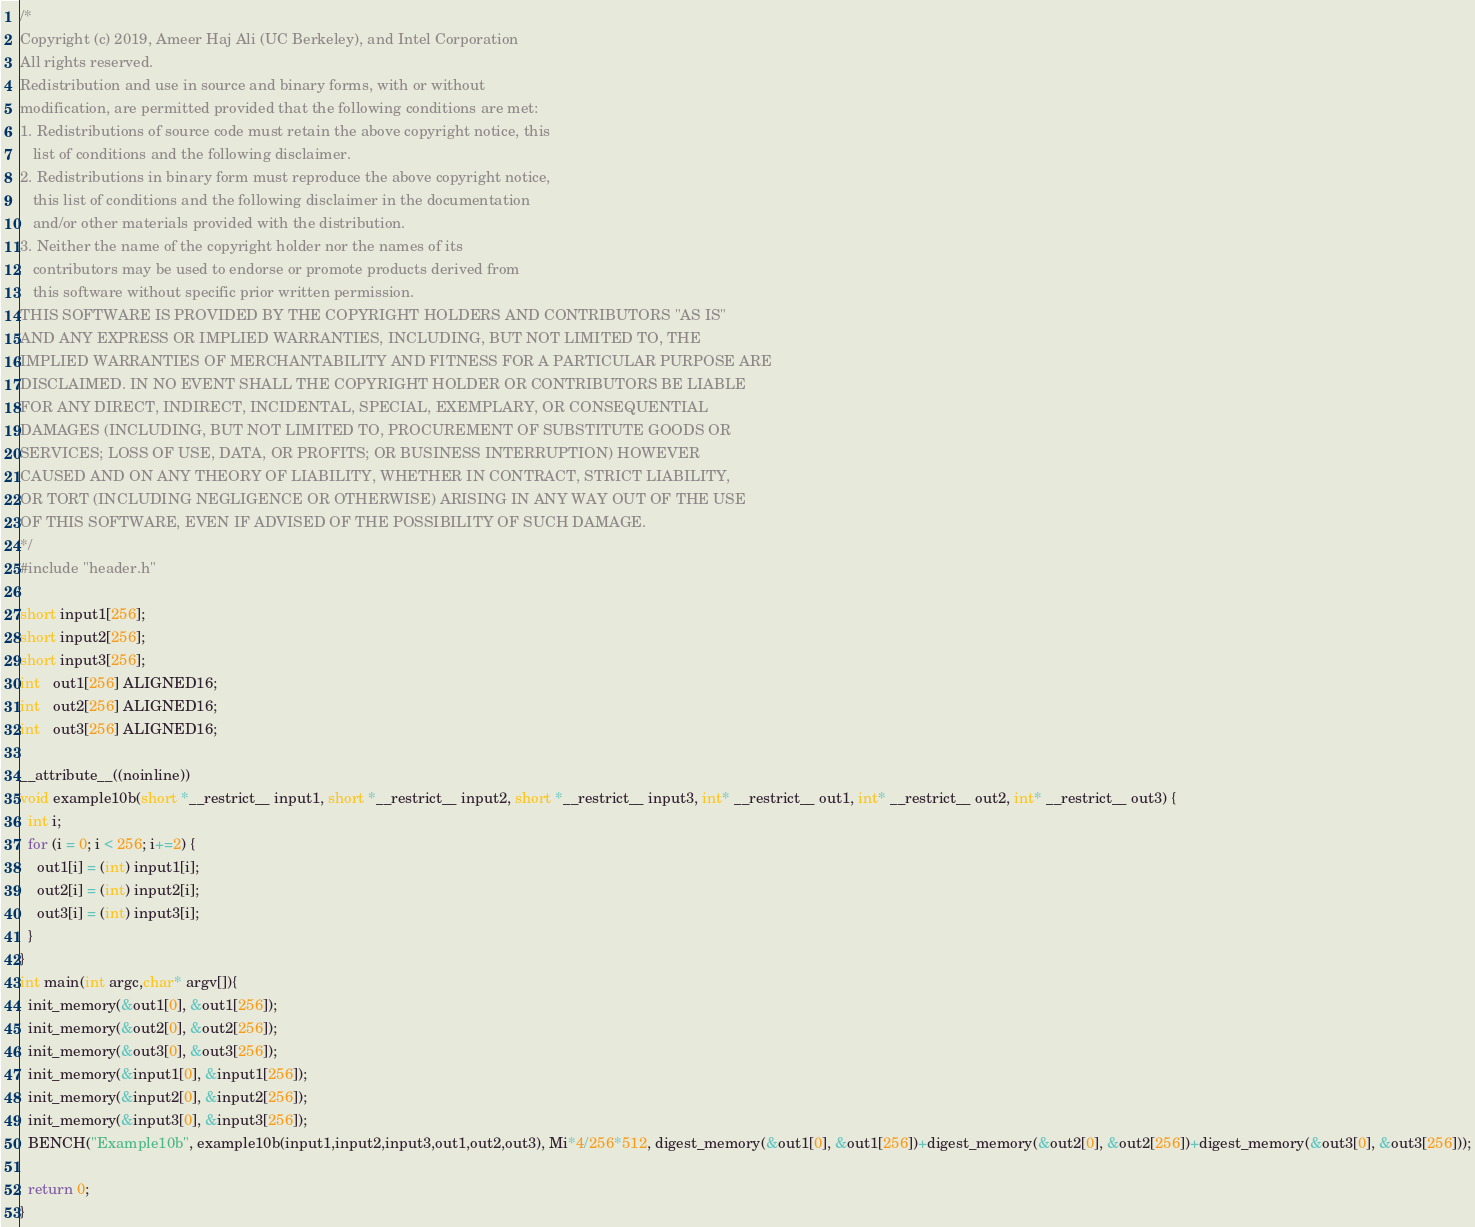<code> <loc_0><loc_0><loc_500><loc_500><_C_>/*
Copyright (c) 2019, Ameer Haj Ali (UC Berkeley), and Intel Corporation
All rights reserved.
Redistribution and use in source and binary forms, with or without
modification, are permitted provided that the following conditions are met:
1. Redistributions of source code must retain the above copyright notice, this
   list of conditions and the following disclaimer.
2. Redistributions in binary form must reproduce the above copyright notice,
   this list of conditions and the following disclaimer in the documentation
   and/or other materials provided with the distribution.
3. Neither the name of the copyright holder nor the names of its
   contributors may be used to endorse or promote products derived from
   this software without specific prior written permission.
THIS SOFTWARE IS PROVIDED BY THE COPYRIGHT HOLDERS AND CONTRIBUTORS "AS IS"
AND ANY EXPRESS OR IMPLIED WARRANTIES, INCLUDING, BUT NOT LIMITED TO, THE
IMPLIED WARRANTIES OF MERCHANTABILITY AND FITNESS FOR A PARTICULAR PURPOSE ARE
DISCLAIMED. IN NO EVENT SHALL THE COPYRIGHT HOLDER OR CONTRIBUTORS BE LIABLE
FOR ANY DIRECT, INDIRECT, INCIDENTAL, SPECIAL, EXEMPLARY, OR CONSEQUENTIAL
DAMAGES (INCLUDING, BUT NOT LIMITED TO, PROCUREMENT OF SUBSTITUTE GOODS OR
SERVICES; LOSS OF USE, DATA, OR PROFITS; OR BUSINESS INTERRUPTION) HOWEVER
CAUSED AND ON ANY THEORY OF LIABILITY, WHETHER IN CONTRACT, STRICT LIABILITY,
OR TORT (INCLUDING NEGLIGENCE OR OTHERWISE) ARISING IN ANY WAY OUT OF THE USE
OF THIS SOFTWARE, EVEN IF ADVISED OF THE POSSIBILITY OF SUCH DAMAGE.
*/
#include "header.h"

short input1[256];
short input2[256];
short input3[256];
int   out1[256] ALIGNED16;
int   out2[256] ALIGNED16;
int   out3[256] ALIGNED16;

__attribute__((noinline))
void example10b(short *__restrict__ input1, short *__restrict__ input2, short *__restrict__ input3, int* __restrict__ out1, int* __restrict__ out2, int* __restrict__ out3) {
  int i;
  for (i = 0; i < 256; i+=2) {
    out1[i] = (int) input1[i];
    out2[i] = (int) input2[i];
    out3[i] = (int) input3[i];
  }
}
int main(int argc,char* argv[]){
  init_memory(&out1[0], &out1[256]);
  init_memory(&out2[0], &out2[256]);
  init_memory(&out3[0], &out3[256]);
  init_memory(&input1[0], &input1[256]);
  init_memory(&input2[0], &input2[256]);
  init_memory(&input3[0], &input3[256]);
  BENCH("Example10b", example10b(input1,input2,input3,out1,out2,out3), Mi*4/256*512, digest_memory(&out1[0], &out1[256])+digest_memory(&out2[0], &out2[256])+digest_memory(&out3[0], &out3[256]));
 
  return 0;
}
</code> 